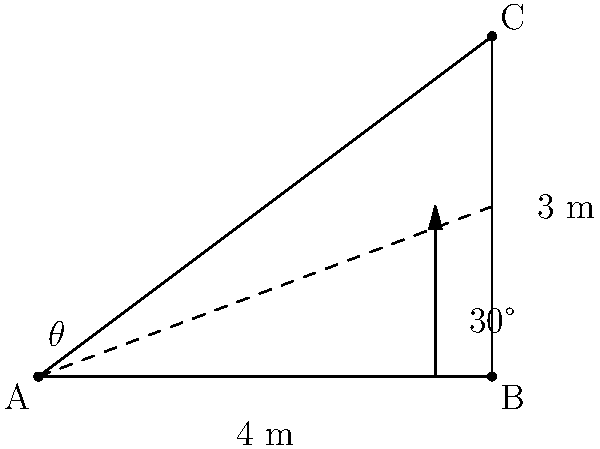In a cross-sectional diagram of an Iranian commercial airliner from the 1960s, the banking angle is represented by $\theta$. Given that the vertical height of the aircraft's wing tip during banking is 3 meters, and the wingspan is 4 meters, calculate the banking angle $\theta$. To solve this problem, we'll use trigonometry:

1) The diagram forms a right-angled triangle ABC.
2) We know the adjacent side (wingspan) = 4 meters
3) We know the opposite side (vertical height) = 3 meters
4) To find the angle $\theta$, we need to use the tangent function

   $\tan(\theta) = \frac{\text{opposite}}{\text{adjacent}} = \frac{3}{4}$

5) To get $\theta$, we need to take the inverse tangent (arctan or $\tan^{-1}$):

   $\theta = \tan^{-1}(\frac{3}{4})$

6) Using a calculator or trigonometric tables:

   $\theta \approx 36.87°$

7) Rounding to the nearest degree:

   $\theta \approx 37°$

This angle represents the banking angle of the Iranian airliner from the 1960s.
Answer: $37°$ 